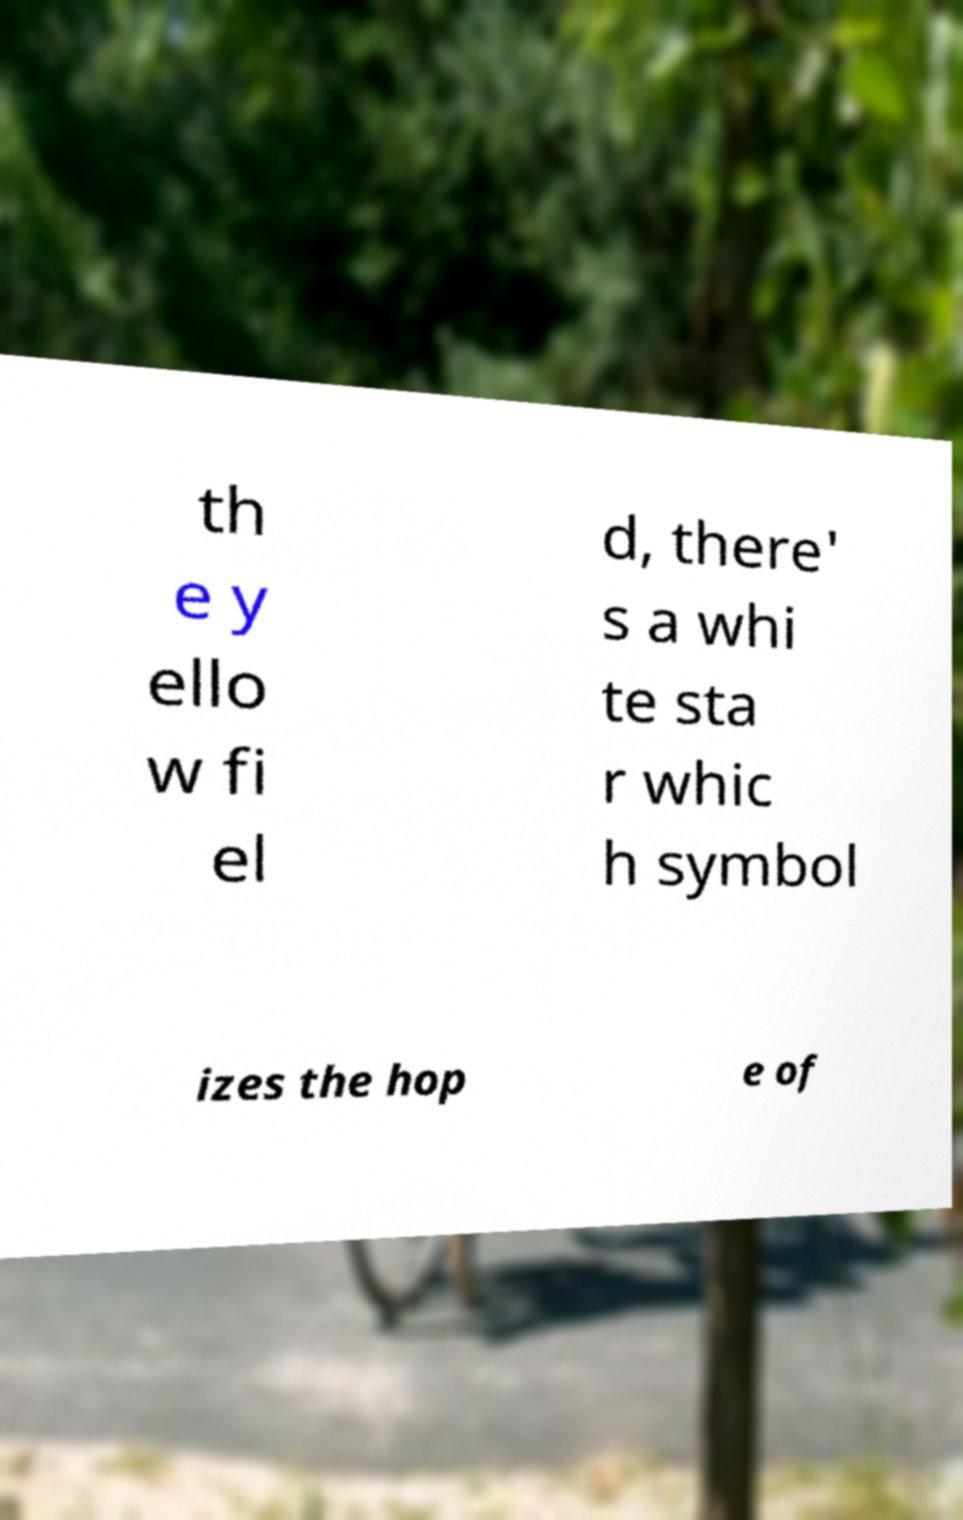What messages or text are displayed in this image? I need them in a readable, typed format. th e y ello w fi el d, there' s a whi te sta r whic h symbol izes the hop e of 